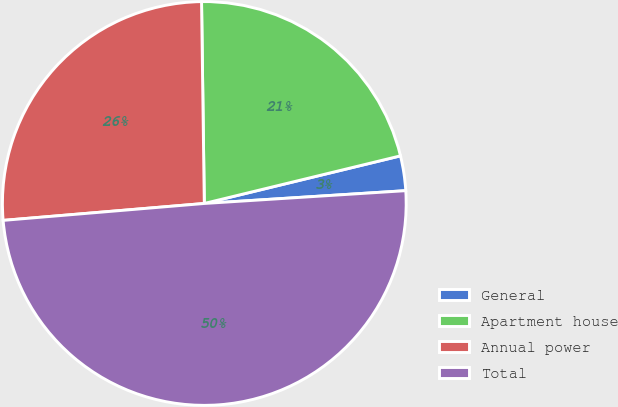Convert chart. <chart><loc_0><loc_0><loc_500><loc_500><pie_chart><fcel>General<fcel>Apartment house<fcel>Annual power<fcel>Total<nl><fcel>2.78%<fcel>21.43%<fcel>26.12%<fcel>49.68%<nl></chart> 